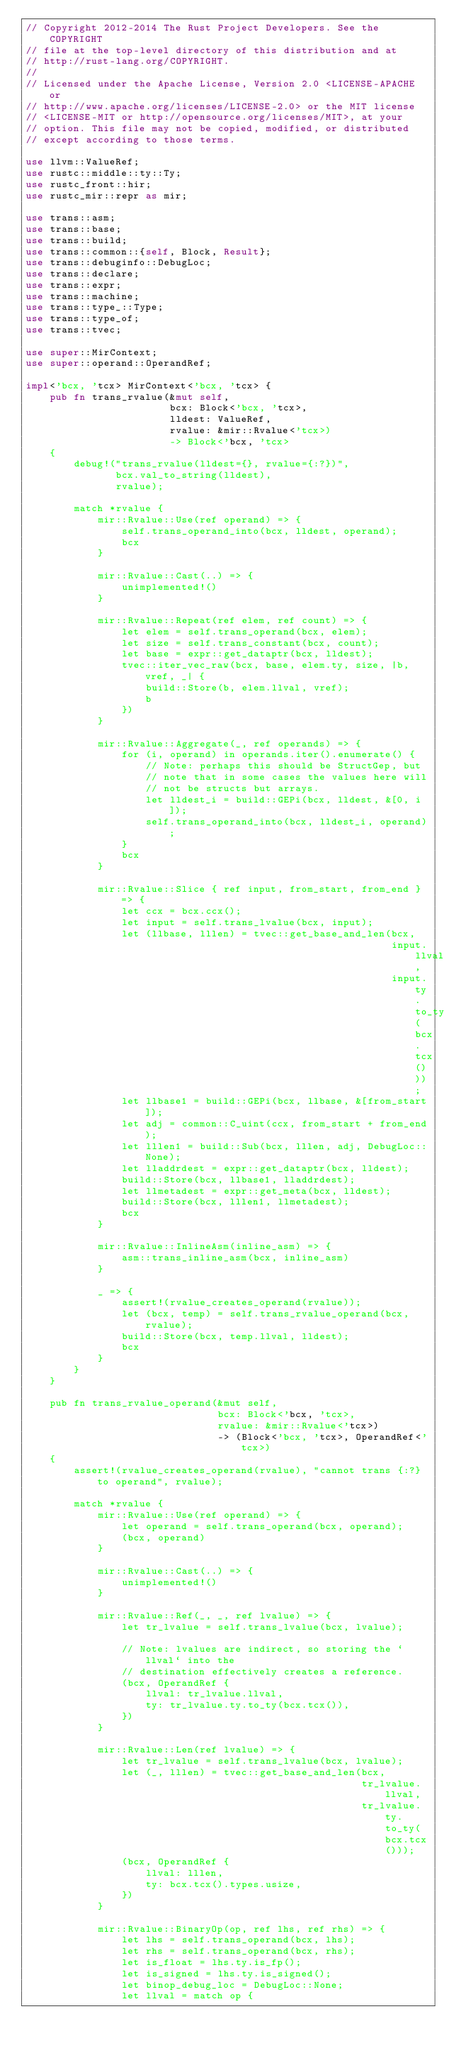<code> <loc_0><loc_0><loc_500><loc_500><_Rust_>// Copyright 2012-2014 The Rust Project Developers. See the COPYRIGHT
// file at the top-level directory of this distribution and at
// http://rust-lang.org/COPYRIGHT.
//
// Licensed under the Apache License, Version 2.0 <LICENSE-APACHE or
// http://www.apache.org/licenses/LICENSE-2.0> or the MIT license
// <LICENSE-MIT or http://opensource.org/licenses/MIT>, at your
// option. This file may not be copied, modified, or distributed
// except according to those terms.

use llvm::ValueRef;
use rustc::middle::ty::Ty;
use rustc_front::hir;
use rustc_mir::repr as mir;

use trans::asm;
use trans::base;
use trans::build;
use trans::common::{self, Block, Result};
use trans::debuginfo::DebugLoc;
use trans::declare;
use trans::expr;
use trans::machine;
use trans::type_::Type;
use trans::type_of;
use trans::tvec;

use super::MirContext;
use super::operand::OperandRef;

impl<'bcx, 'tcx> MirContext<'bcx, 'tcx> {
    pub fn trans_rvalue(&mut self,
                        bcx: Block<'bcx, 'tcx>,
                        lldest: ValueRef,
                        rvalue: &mir::Rvalue<'tcx>)
                        -> Block<'bcx, 'tcx>
    {
        debug!("trans_rvalue(lldest={}, rvalue={:?})",
               bcx.val_to_string(lldest),
               rvalue);

        match *rvalue {
            mir::Rvalue::Use(ref operand) => {
                self.trans_operand_into(bcx, lldest, operand);
                bcx
            }

            mir::Rvalue::Cast(..) => {
                unimplemented!()
            }

            mir::Rvalue::Repeat(ref elem, ref count) => {
                let elem = self.trans_operand(bcx, elem);
                let size = self.trans_constant(bcx, count);
                let base = expr::get_dataptr(bcx, lldest);
                tvec::iter_vec_raw(bcx, base, elem.ty, size, |b, vref, _| {
                    build::Store(b, elem.llval, vref);
                    b
                })
            }

            mir::Rvalue::Aggregate(_, ref operands) => {
                for (i, operand) in operands.iter().enumerate() {
                    // Note: perhaps this should be StructGep, but
                    // note that in some cases the values here will
                    // not be structs but arrays.
                    let lldest_i = build::GEPi(bcx, lldest, &[0, i]);
                    self.trans_operand_into(bcx, lldest_i, operand);
                }
                bcx
            }

            mir::Rvalue::Slice { ref input, from_start, from_end } => {
                let ccx = bcx.ccx();
                let input = self.trans_lvalue(bcx, input);
                let (llbase, lllen) = tvec::get_base_and_len(bcx,
                                                             input.llval,
                                                             input.ty.to_ty(bcx.tcx()));
                let llbase1 = build::GEPi(bcx, llbase, &[from_start]);
                let adj = common::C_uint(ccx, from_start + from_end);
                let lllen1 = build::Sub(bcx, lllen, adj, DebugLoc::None);
                let lladdrdest = expr::get_dataptr(bcx, lldest);
                build::Store(bcx, llbase1, lladdrdest);
                let llmetadest = expr::get_meta(bcx, lldest);
                build::Store(bcx, lllen1, llmetadest);
                bcx
            }

            mir::Rvalue::InlineAsm(inline_asm) => {
                asm::trans_inline_asm(bcx, inline_asm)
            }

            _ => {
                assert!(rvalue_creates_operand(rvalue));
                let (bcx, temp) = self.trans_rvalue_operand(bcx, rvalue);
                build::Store(bcx, temp.llval, lldest);
                bcx
            }
        }
    }

    pub fn trans_rvalue_operand(&mut self,
                                bcx: Block<'bcx, 'tcx>,
                                rvalue: &mir::Rvalue<'tcx>)
                                -> (Block<'bcx, 'tcx>, OperandRef<'tcx>)
    {
        assert!(rvalue_creates_operand(rvalue), "cannot trans {:?} to operand", rvalue);

        match *rvalue {
            mir::Rvalue::Use(ref operand) => {
                let operand = self.trans_operand(bcx, operand);
                (bcx, operand)
            }

            mir::Rvalue::Cast(..) => {
                unimplemented!()
            }

            mir::Rvalue::Ref(_, _, ref lvalue) => {
                let tr_lvalue = self.trans_lvalue(bcx, lvalue);

                // Note: lvalues are indirect, so storing the `llval` into the
                // destination effectively creates a reference.
                (bcx, OperandRef {
                    llval: tr_lvalue.llval,
                    ty: tr_lvalue.ty.to_ty(bcx.tcx()),
                })
            }

            mir::Rvalue::Len(ref lvalue) => {
                let tr_lvalue = self.trans_lvalue(bcx, lvalue);
                let (_, lllen) = tvec::get_base_and_len(bcx,
                                                        tr_lvalue.llval,
                                                        tr_lvalue.ty.to_ty(bcx.tcx()));
                (bcx, OperandRef {
                    llval: lllen,
                    ty: bcx.tcx().types.usize,
                })
            }

            mir::Rvalue::BinaryOp(op, ref lhs, ref rhs) => {
                let lhs = self.trans_operand(bcx, lhs);
                let rhs = self.trans_operand(bcx, rhs);
                let is_float = lhs.ty.is_fp();
                let is_signed = lhs.ty.is_signed();
                let binop_debug_loc = DebugLoc::None;
                let llval = match op {</code> 